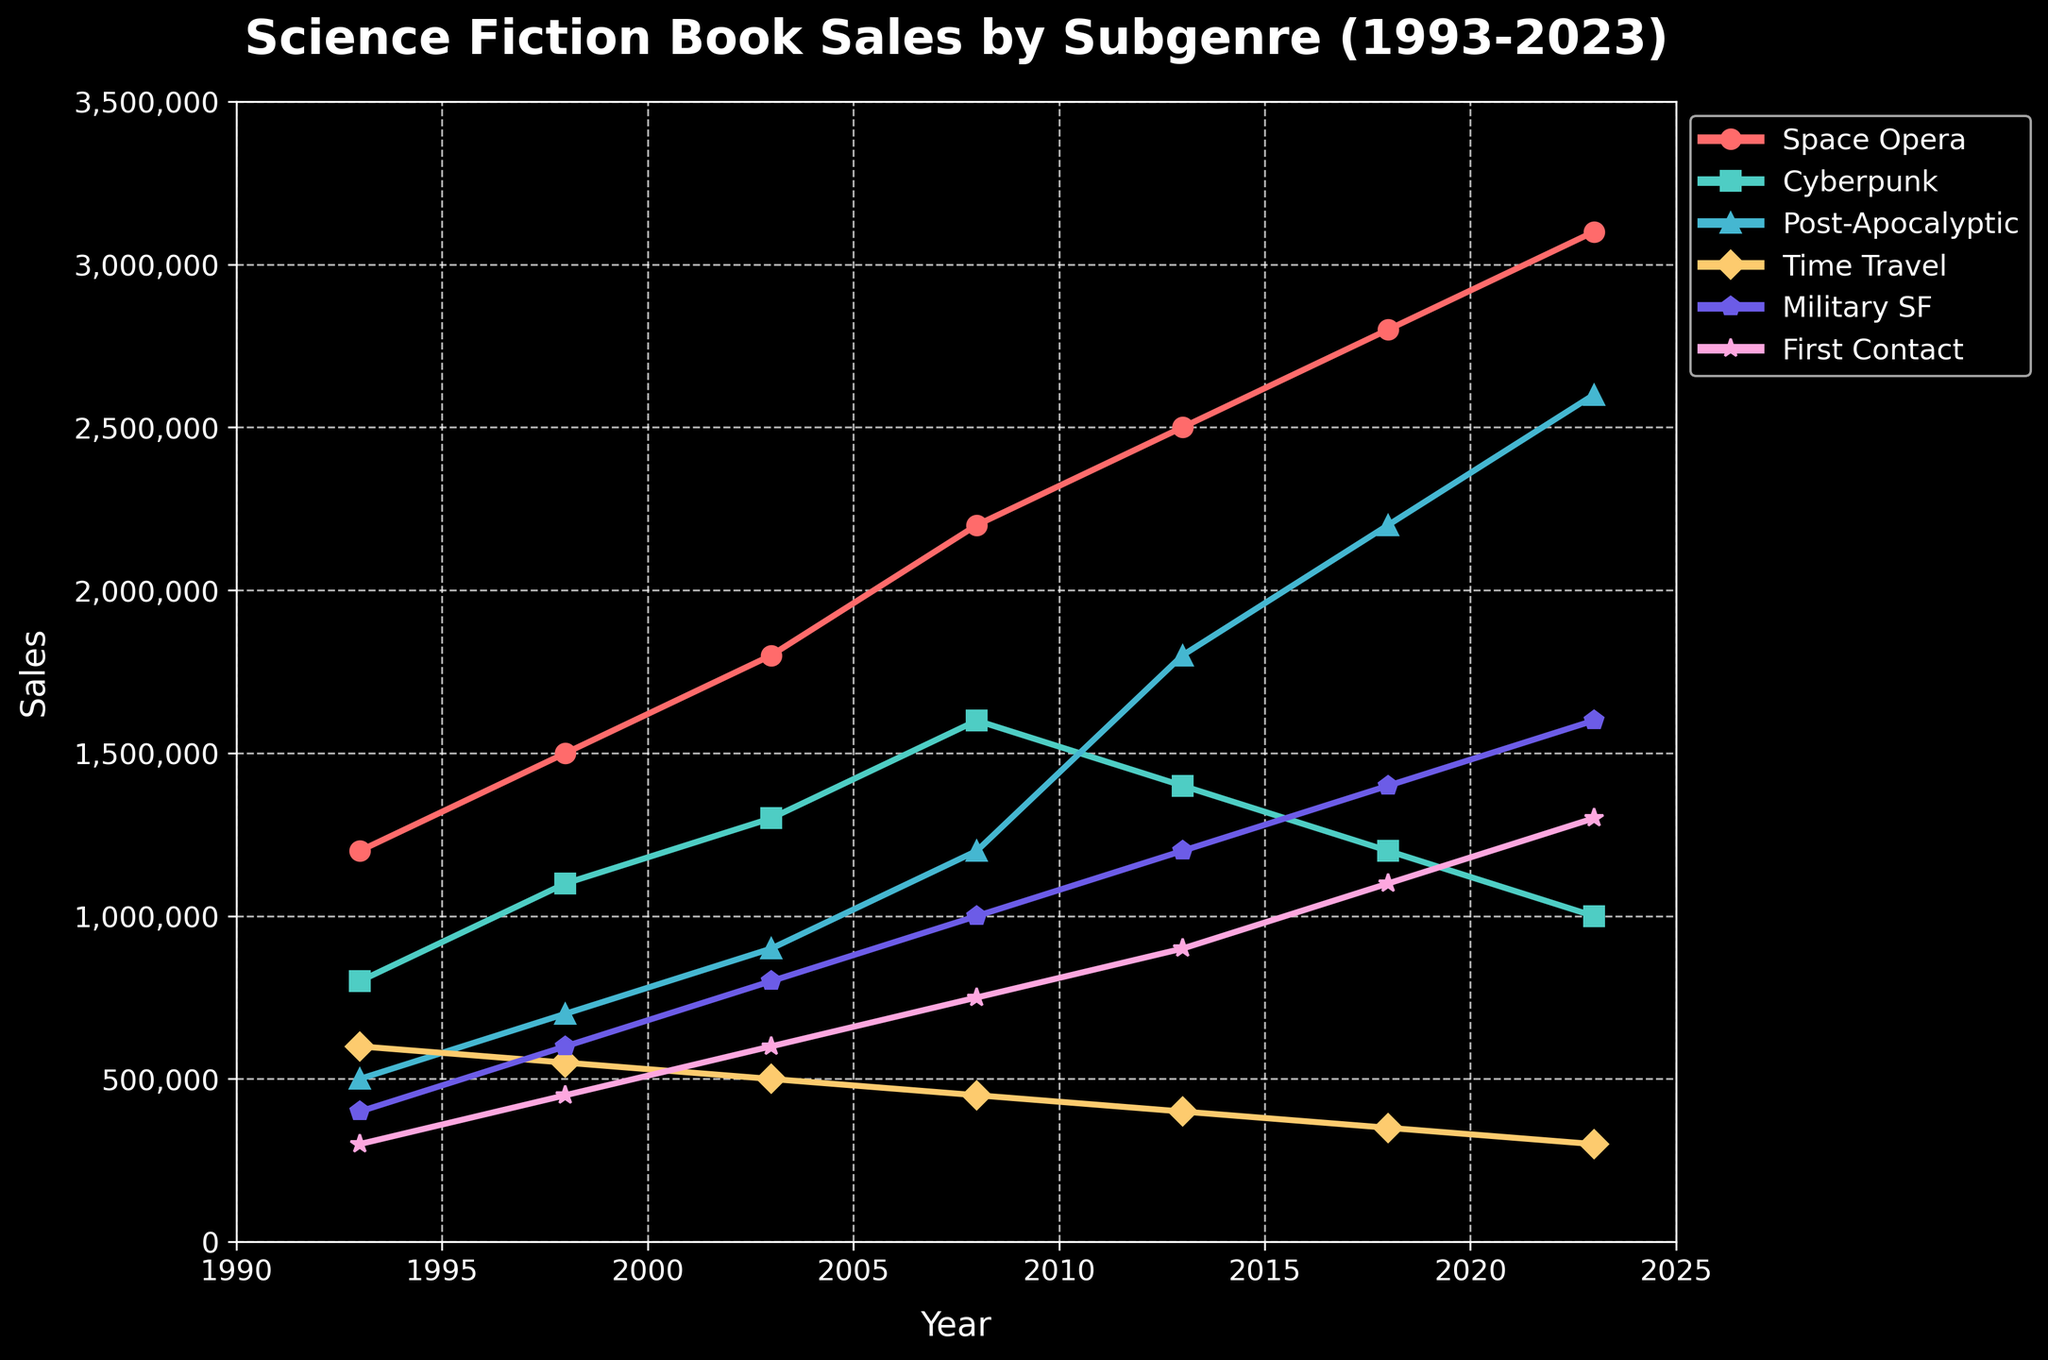What subgenre had the highest sales in 2023? Look at the 2023 data on the chart and identify the subgenre with the highest vertical point.
Answer: Space Opera Which year did Cyberpunk sales start to decline? Observe the trend for Cyberpunk; it peaks around 2008 and starts declining afterward.
Answer: 2008 By how much did sales of Post-Apocalyptic books increase from 1993 to 2023? Subtract the 1993 sales value from the 2023 sales value for Post-Apocalyptic. 2600000 (2023) - 500000 (1993) = 2100000
Answer: 2100000 Which subgenre saw a decline in sales between 2013 and 2018? Check the sales values for each subgenre in 2013 and 2018 and identify any that decreased. Cyberpunk decreases from 1400000 to 1200000.
Answer: Cyberpunk What is the overall trend in sales for Military SF over the entire period? Look at the line representing Military SF. It consistently increases from 1993 to 2023.
Answer: Increasing Which subgenre has the least variation in sales over the 30-year period? Compare the range of sales values (difference between highest and lowest value) for each subgenre. Time Travel has the least variation, from 600000 to 300000.
Answer: Time Travel In which year did First Contact sales surpass 1,000,000? Locate the point on the First Contact line where it first exceeds 1,000,000, which happens between 2013 and 2018.
Answer: 2018 What is the combined sales of Cyberpunk and Post-Apocalyptic books in 2008? Add the sales numbers for Cyberpunk and Post-Apocalyptic in 2008. 1600000 + 1200000 = 2800000
Answer: 2800000 Which subgenre had the most consistent rise in sales over the 30 years? Identify the line that shows consistent upward movement without sudden drops over the period. Space Opera shows a steady rise.
Answer: Space Opera How much did the sales of Time Travel books drop from 1993 to 2023? Subtract the 2023 value from the 1993 value for Time Travel. 600000 (1993) - 300000 (2023) = 300000
Answer: 300000 